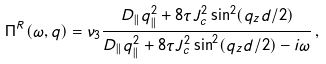Convert formula to latex. <formula><loc_0><loc_0><loc_500><loc_500>\Pi ^ { R } ( \omega , q ) = \nu _ { 3 } \frac { D _ { \| } q _ { \| } ^ { 2 } + 8 \tau J _ { c } ^ { 2 } \sin ^ { 2 } ( q _ { z } d / 2 ) } { D _ { \| } q _ { \| } ^ { 2 } + 8 \tau J _ { c } ^ { 2 } \sin ^ { 2 } ( q _ { z } d / 2 ) - i \omega } \, ,</formula> 